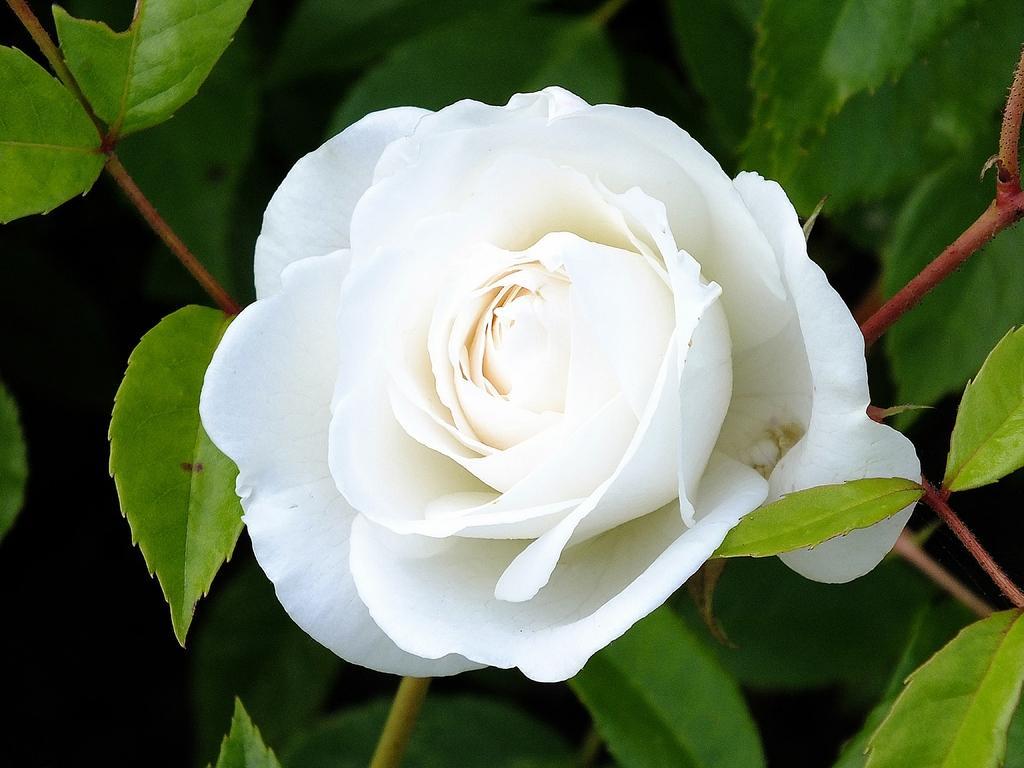Describe this image in one or two sentences. In this picture I can see there is a white rose flower and it has few petals and is attached to the plant and there are leafs. 